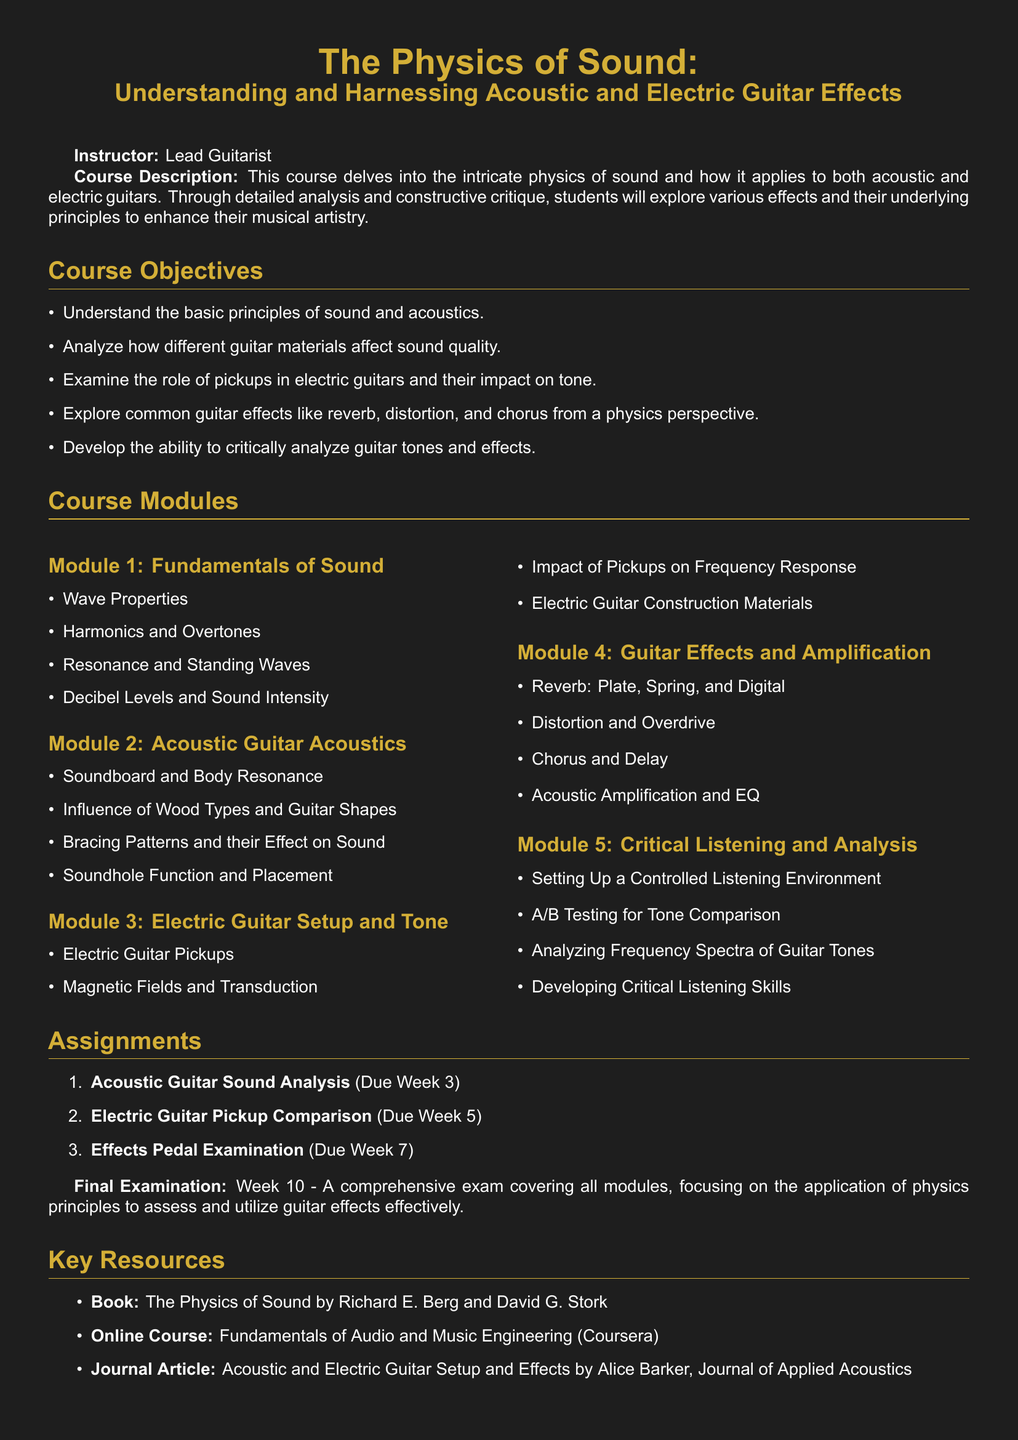What is the course title? The title is prominently displayed at the top of the document, indicating the subject of the syllabus.
Answer: The Physics of Sound: Understanding and Harnessing Acoustic and Electric Guitar Effects Who is the instructor? The instructor's name is stated with their role in the course at the beginning of the syllabus.
Answer: Lead Guitarist How many course modules are there? The syllabus specifies the number of modules included in the course outline.
Answer: Five What is the due date for the Acoustic Guitar Sound Analysis assignment? The due date for the first assignment is mentioned in the assignment section of the syllabus.
Answer: Week 3 Which book is listed as a key resource? The document provides a reference for a key text that supports the course material.
Answer: The Physics of Sound by Richard E. Berg and David G. Stork What is the focus of Module 4? This module's title indicates its primary subject matter regarding guitar effects.
Answer: Guitar Effects and Amplification What type of listening skills does Module 5 aim to develop? The title of Module 5 clearly states the skills that will be cultivated in this course segment.
Answer: Critical Listening Skills What is the final examination week? The document outlines the scheduling of the final assessment, specifying when it will take place.
Answer: Week 10 